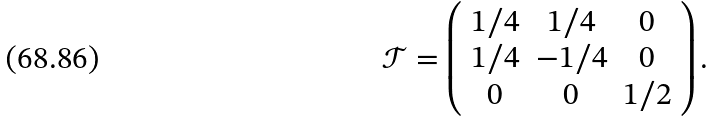<formula> <loc_0><loc_0><loc_500><loc_500>\mathcal { T } = \left ( \begin{array} { c c c } 1 / 4 & 1 / 4 & 0 \\ 1 / 4 & - 1 / 4 & 0 \\ 0 & 0 & 1 / 2 \end{array} \right ) .</formula> 